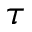Convert formula to latex. <formula><loc_0><loc_0><loc_500><loc_500>\tau</formula> 